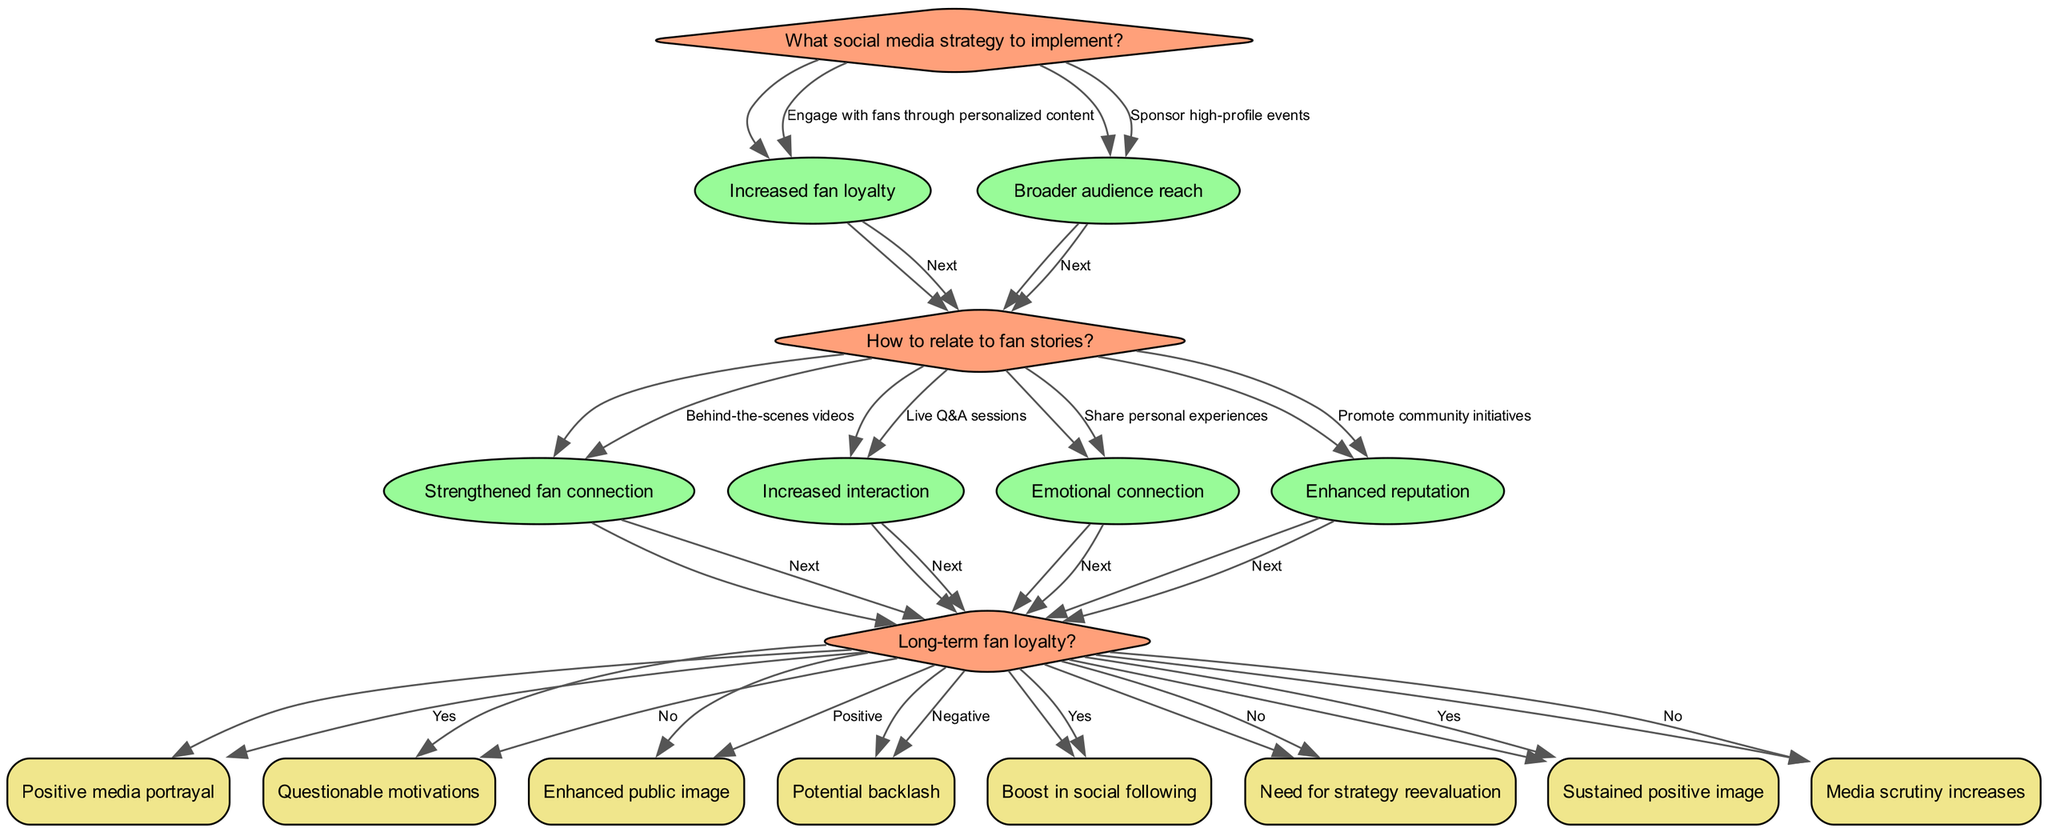What is the root question of the decision tree? The diagram's root question is displayed at the top and asks what social media strategy to implement.
Answer: What social media strategy to implement? How many options does the root question provide? The root question offers two options: "Engage with fans through personalized content" and "Sponsor high-profile events." Thus, there are two options in total.
Answer: 2 What is the impact of engaging with fans through personalized content? When choosing to engage with fans through personalized content, the specified impact in the diagram is "Increased fan loyalty."
Answer: Increased fan loyalty What is the next question after choosing to share behind-the-scenes videos? After selecting the option to share behind-the-scenes videos, the next question posed is about the valorization of authenticity.
Answer: Valorization of authenticity? If the outcome after a live Q&A session is positive, what is the result on public image? When the outcome from a live Q&A session is categorized as positive, the resulting impact indicated is "Enhanced public image."
Answer: Enhanced public image What happens if fans do not engage with shared personal experiences? If the outcome from sharing personal experiences is negative, the diagram suggests a need for strategy reevaluation.
Answer: Need for strategy reevaluation What are the two pathways following the sponsorship of high-profile events? Sponsoring high-profile events leads to two pathways: one involving sharing personal experiences and the other promoting community initiatives.
Answer: Share personal experiences, Promote community initiatives How does promoting community initiatives affect long-term fan loyalty? The diagram indicates that promoting community initiatives can lead to sustained positive image if fan loyalty is achieved. If not, it states that media scrutiny increases.
Answer: Sustained positive image, Media scrutiny increases 